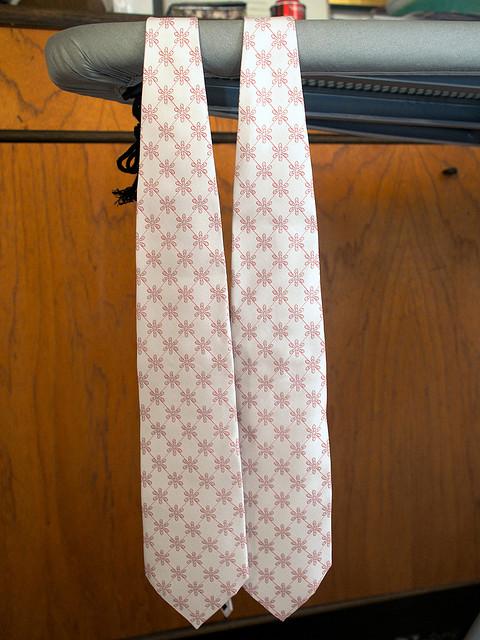Are the ties wrinkled?
Write a very short answer. No. What are the ties hanging off of?
Concise answer only. Ironing board. Are the ties identical?
Answer briefly. Yes. 